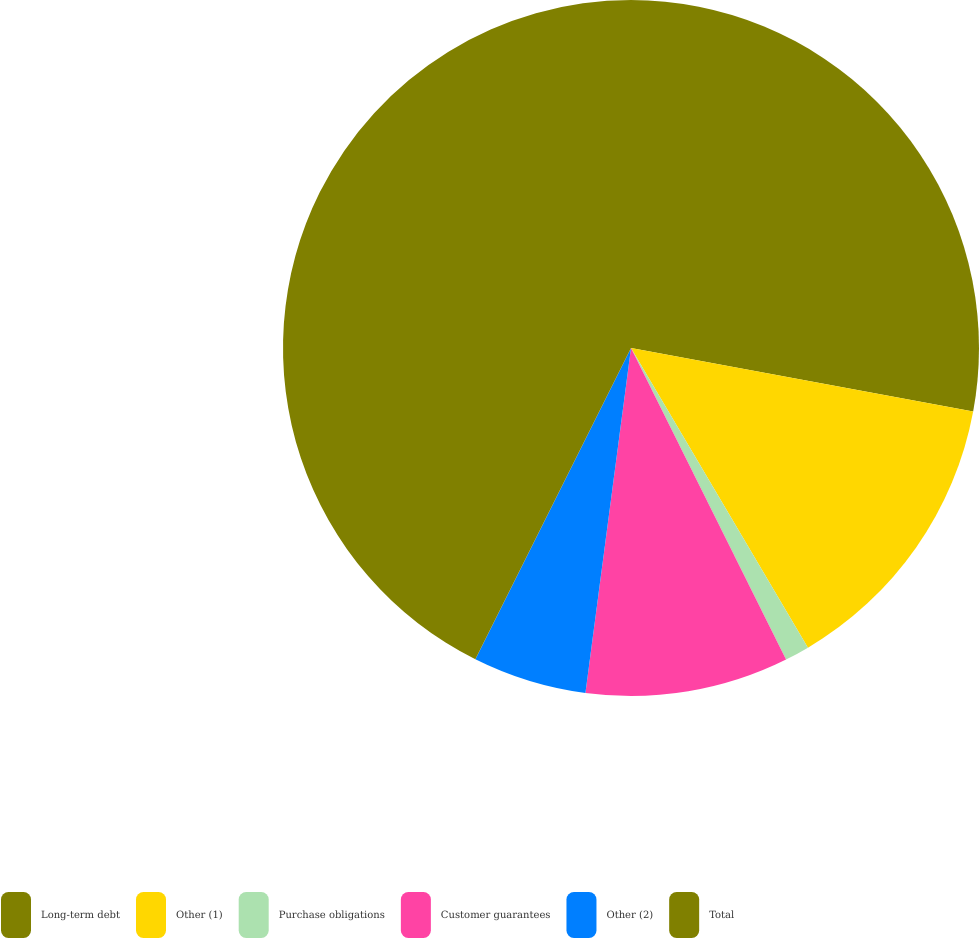<chart> <loc_0><loc_0><loc_500><loc_500><pie_chart><fcel>Long-term debt<fcel>Other (1)<fcel>Purchase obligations<fcel>Customer guarantees<fcel>Other (2)<fcel>Total<nl><fcel>27.92%<fcel>13.59%<fcel>1.14%<fcel>9.44%<fcel>5.29%<fcel>42.62%<nl></chart> 